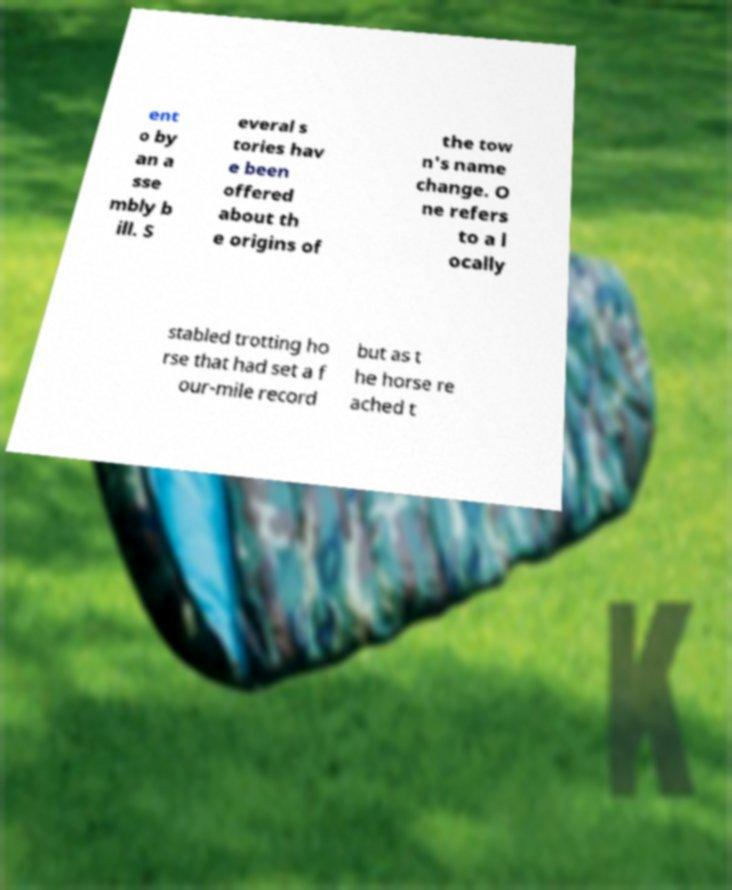Can you read and provide the text displayed in the image?This photo seems to have some interesting text. Can you extract and type it out for me? ent o by an a sse mbly b ill. S everal s tories hav e been offered about th e origins of the tow n's name change. O ne refers to a l ocally stabled trotting ho rse that had set a f our-mile record but as t he horse re ached t 